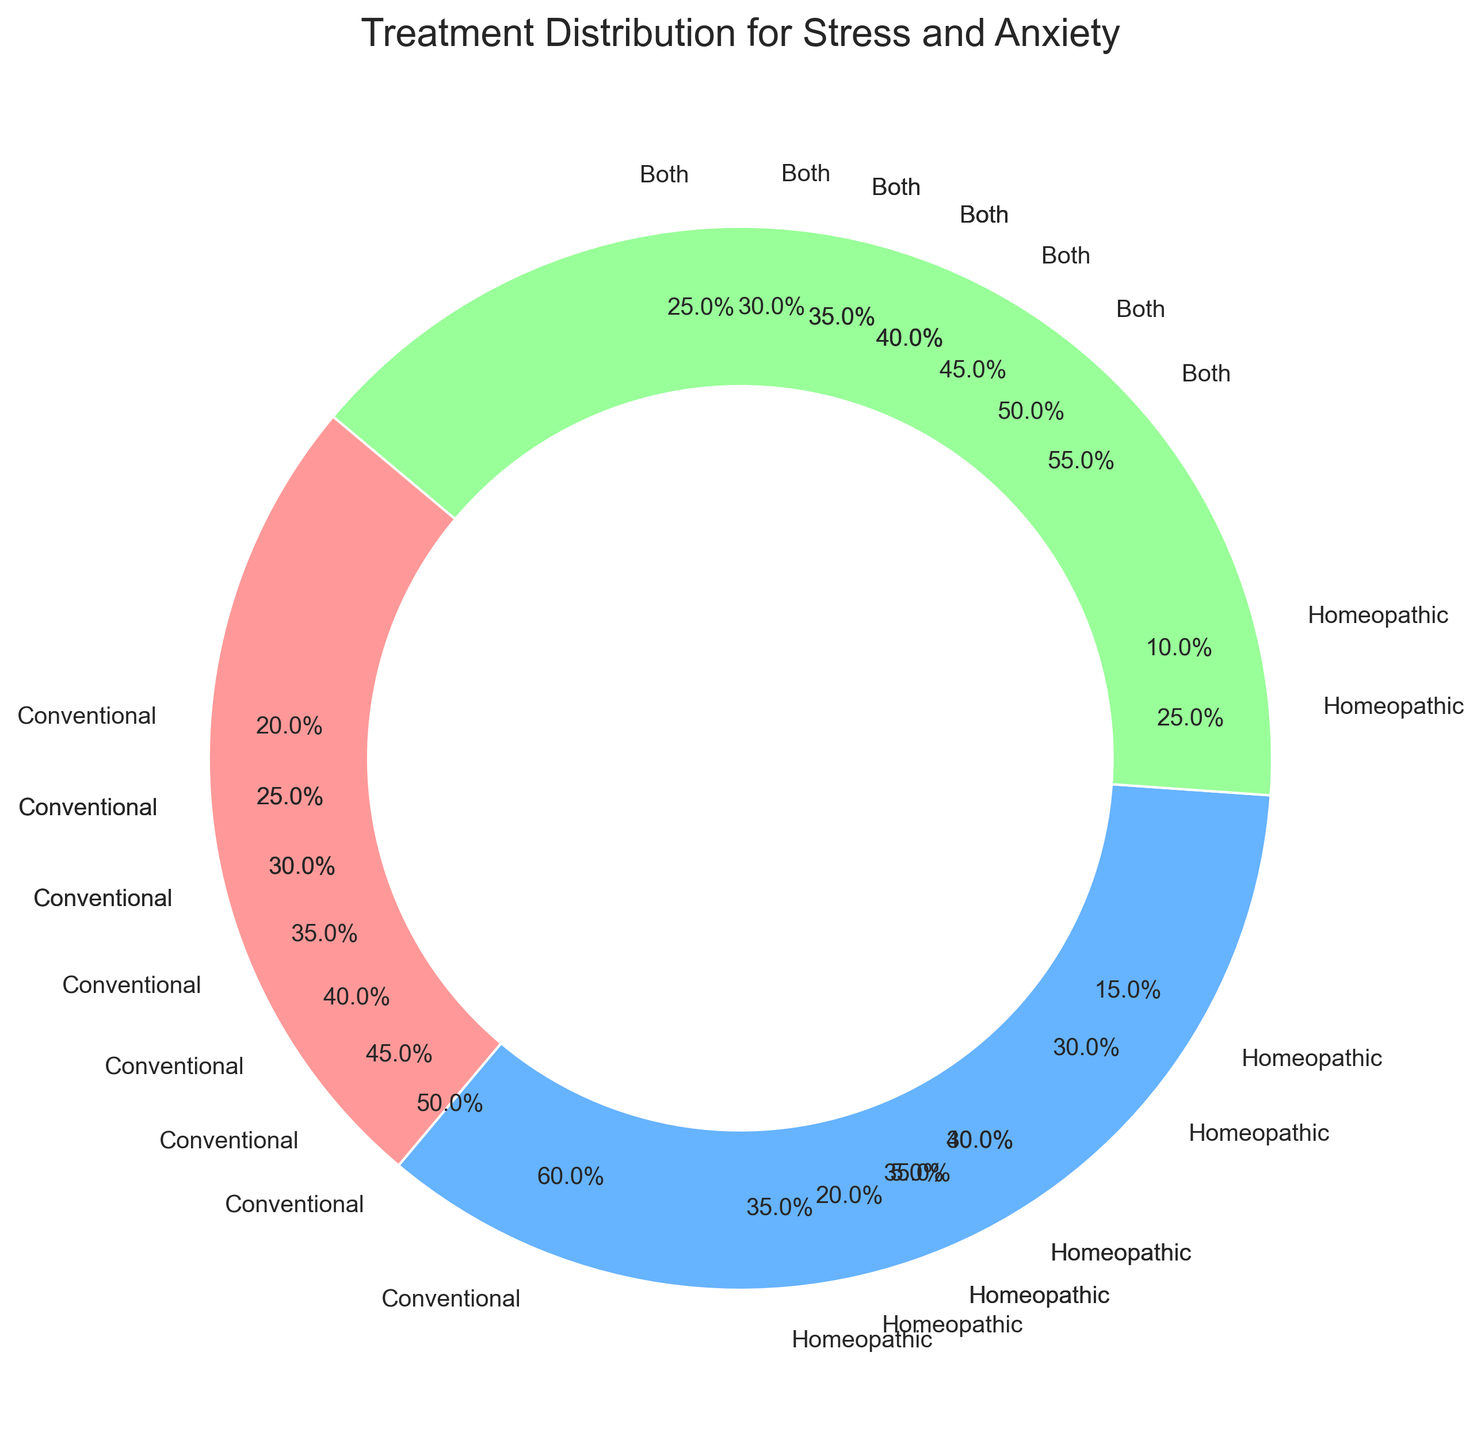Which condition has the highest percentage of treatment with conventional medicine? To find the condition with the highest percentage of treatment using conventional medicine, look at the segments labeled "Conventional" and check which has the largest percentage. Influenza has a 60% treatment rate with conventional medicine, which is the highest.
Answer: Influenza Between headaches and digestive issues, which has a higher percentage of being treated with both conventional and homeopathic remedies? Compare the percentage of treatment categorized as "Both" for headaches and digestive issues. Headaches have 40% treated with both, while digestive issues have 35%.
Answer: Headaches Which condition has nearly equal distribution among conventional, homeopathic, and both treatments? Looking for the condition where the percentages for conventional, homeopathic, and both are closest to each other. Digestive issues have 35% conventional, 30% homeopathic, and 35% both, which are relatively balanced.
Answer: Digestive issues What percentage of asthma treatments involve both conventional and homeopathic remedies? Locate the pie chart segment for asthma and find the segment labeled "Both". Asthma treatments are 55% involving both conventional and homeopathic remedies.
Answer: 55% How does the treatment distribution for stress and anxiety compare to that of joint pain? Compare the percentages in the segments for stress and anxiety (25% conventional, 35% homeopathic, 40% both) and joint pain (25% conventional, 40% homeopathic, 35% both). Both conditions have equal percentages for conventional treatments, but stress and anxiety have a slightly higher percentage for both compared to joint pain.
Answer: Similar, with stress and anxiety having slightly higher "both" treatment If you combine the percentages for conventional medicine in treating allergies and common cold, what is the total percentage? Add the conventional treatment percentages for allergies (30%) and common cold (50%). 30% + 50% equals 80%.
Answer: 80% Which condition relies the least on homeopathic remedies for treatment, according to the chart? Find the condition with the smallest segment labeled "Homeopathic". Asthma has the smallest percentage for homeopathic treatment at 5%.
Answer: Asthma How does the percentage of conventional treatment for skin conditions compare to that for headaches? Compare the percentage of conventional treatment segments for skin conditions (30%) and headaches (45%). 30% for skin conditions is less than 45% for headaches.
Answer: Less for skin conditions What is the average percentage of combined treatment (both conventional and homeopathic) across all conditions? Sum all the percentages in the "Both" category across all conditions and divide by the number of conditions. Sum: 50+55+25+35+40+30+45+35+40+40 = 395. Average = 395/10 = 39.5%.
Answer: 39.5% Which condition has the highest reliance on homeopathic treatment, and what percentage is it? Identify the condition with the largest segment for homeopathic treatment. Joint pain has the highest percentage for homeopathic treatment at 40%.
Answer: Joint pain, 40% 